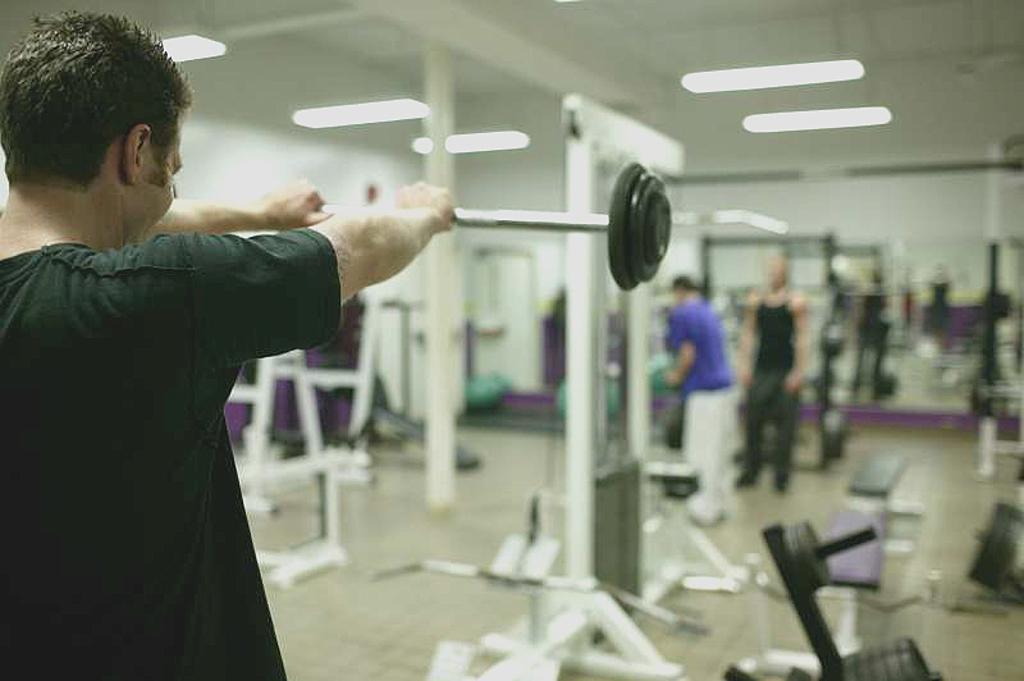In one or two sentences, can you explain what this image depicts? On the left side of the image we can see a man lifting weights. There are stands. We can see people. In the background there is a wall. At the top there are lights. 